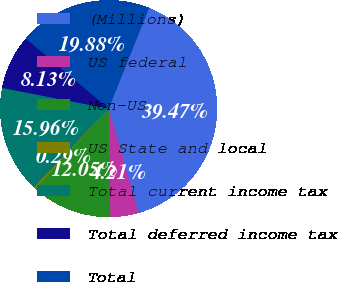<chart> <loc_0><loc_0><loc_500><loc_500><pie_chart><fcel>(Millions)<fcel>US federal<fcel>Non-US<fcel>US State and local<fcel>Total current income tax<fcel>Total deferred income tax<fcel>Total<nl><fcel>39.47%<fcel>4.21%<fcel>12.05%<fcel>0.29%<fcel>15.96%<fcel>8.13%<fcel>19.88%<nl></chart> 